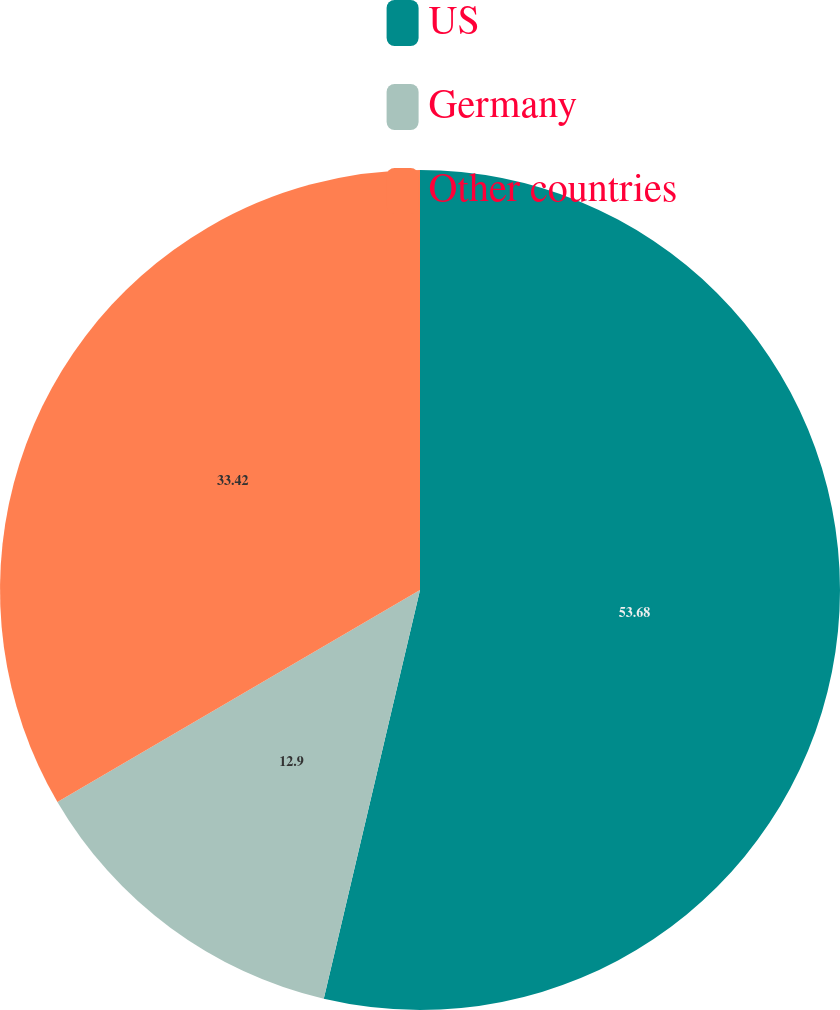Convert chart to OTSL. <chart><loc_0><loc_0><loc_500><loc_500><pie_chart><fcel>US<fcel>Germany<fcel>Other countries<nl><fcel>53.68%<fcel>12.9%<fcel>33.42%<nl></chart> 